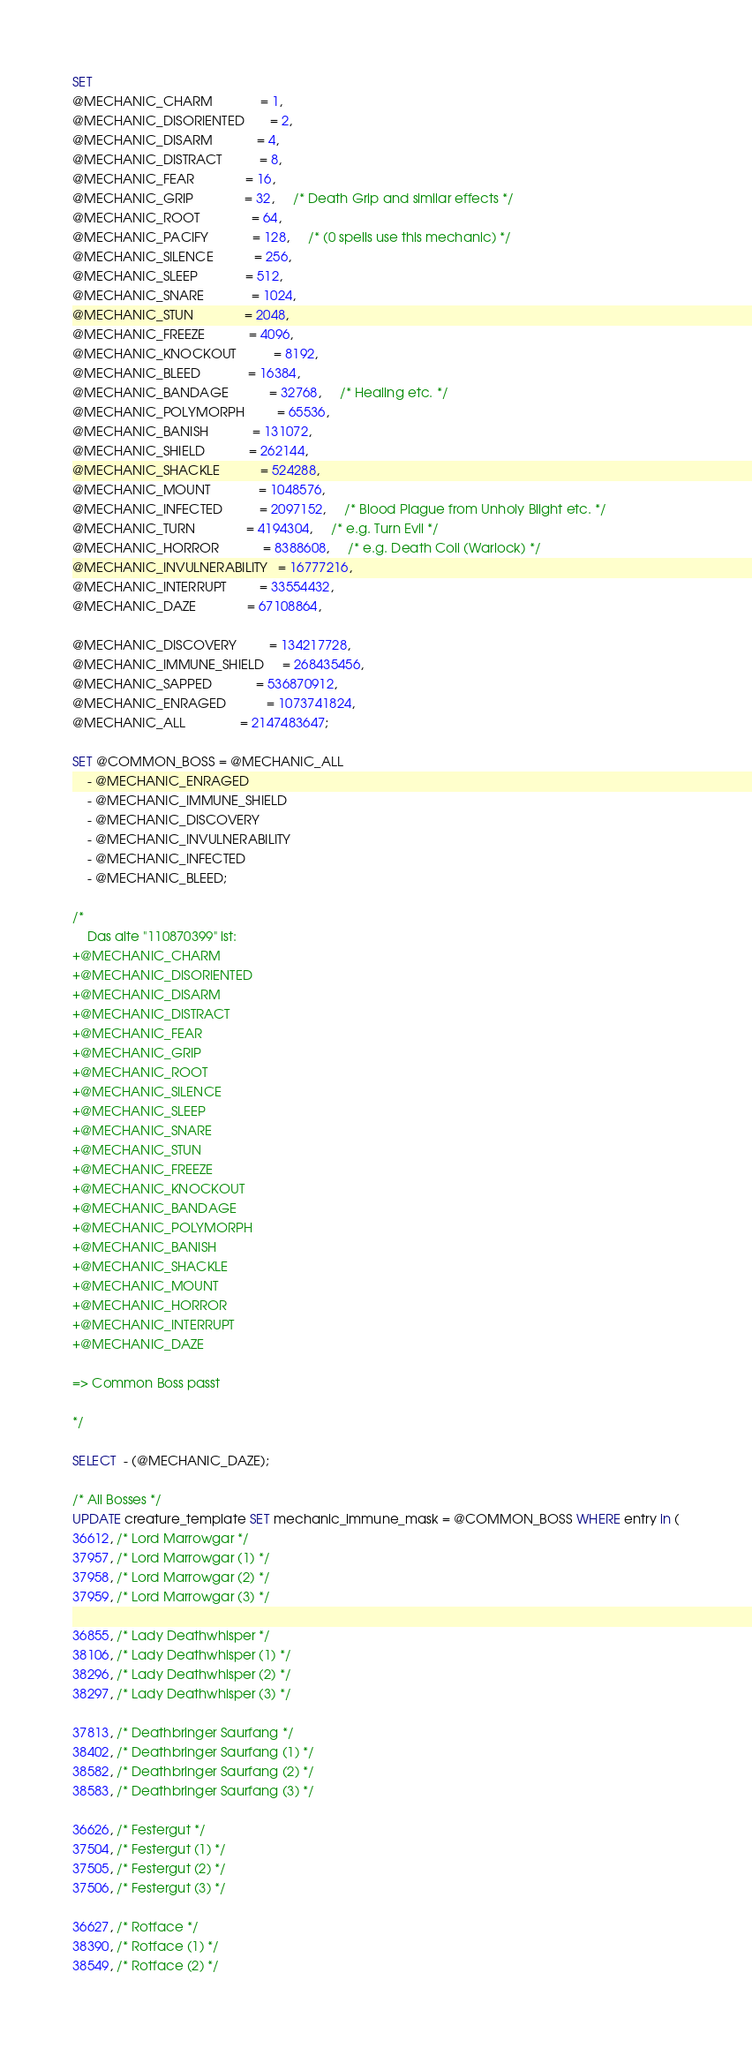Convert code to text. <code><loc_0><loc_0><loc_500><loc_500><_SQL_>SET 
@MECHANIC_CHARM             = 1,
@MECHANIC_DISORIENTED       = 2,     
@MECHANIC_DISARM            = 4,
@MECHANIC_DISTRACT          = 8,     
@MECHANIC_FEAR              = 16,     
@MECHANIC_GRIP              = 32,     /* Death Grip and similar effects */
@MECHANIC_ROOT              = 64,     
@MECHANIC_PACIFY            = 128,     /* (0 spells use this mechanic) */
@MECHANIC_SILENCE           = 256,     
@MECHANIC_SLEEP             = 512,     
@MECHANIC_SNARE             = 1024,     
@MECHANIC_STUN              = 2048,     
@MECHANIC_FREEZE            = 4096,     
@MECHANIC_KNOCKOUT          = 8192,     
@MECHANIC_BLEED             = 16384,     
@MECHANIC_BANDAGE           = 32768,     /* Healing etc. */
@MECHANIC_POLYMORPH         = 65536,     
@MECHANIC_BANISH            = 131072,     
@MECHANIC_SHIELD            = 262144,     
@MECHANIC_SHACKLE           = 524288,     
@MECHANIC_MOUNT             = 1048576,     
@MECHANIC_INFECTED          = 2097152,     /* Blood Plague from Unholy Blight etc. */
@MECHANIC_TURN              = 4194304,     /* e.g. Turn Evil */
@MECHANIC_HORROR            = 8388608,     /* e.g. Death Coil (Warlock) */
@MECHANIC_INVULNERABILITY   = 16777216,     
@MECHANIC_INTERRUPT         = 33554432,     
@MECHANIC_DAZE              = 67108864,
															
@MECHANIC_DISCOVERY         = 134217728,
@MECHANIC_IMMUNE_SHIELD     = 268435456,     
@MECHANIC_SAPPED            = 536870912,     
@MECHANIC_ENRAGED           = 1073741824,    
@MECHANIC_ALL               = 2147483647;

SET @COMMON_BOSS = @MECHANIC_ALL 
    - @MECHANIC_ENRAGED
    - @MECHANIC_IMMUNE_SHIELD
    - @MECHANIC_DISCOVERY
    - @MECHANIC_INVULNERABILITY
    - @MECHANIC_INFECTED
    - @MECHANIC_BLEED;
    
/*
	Das alte "110870399" ist:
+@MECHANIC_CHARM
+@MECHANIC_DISORIENTED
+@MECHANIC_DISARM
+@MECHANIC_DISTRACT
+@MECHANIC_FEAR
+@MECHANIC_GRIP
+@MECHANIC_ROOT
+@MECHANIC_SILENCE
+@MECHANIC_SLEEP
+@MECHANIC_SNARE
+@MECHANIC_STUN
+@MECHANIC_FREEZE
+@MECHANIC_KNOCKOUT
+@MECHANIC_BANDAGE
+@MECHANIC_POLYMORPH
+@MECHANIC_BANISH
+@MECHANIC_SHACKLE
+@MECHANIC_MOUNT
+@MECHANIC_HORROR
+@MECHANIC_INTERRUPT
+@MECHANIC_DAZE

=> Common Boss passt

*/    

SELECT  - (@MECHANIC_DAZE);

/* All Bosses */
UPDATE creature_template SET mechanic_immune_mask = @COMMON_BOSS WHERE entry in (
36612, /* Lord Marrowgar */
37957, /* Lord Marrowgar (1) */
37958, /* Lord Marrowgar (2) */
37959, /* Lord Marrowgar (3) */

36855, /* Lady Deathwhisper */
38106, /* Lady Deathwhisper (1) */
38296, /* Lady Deathwhisper (2) */
38297, /* Lady Deathwhisper (3) */

37813, /* Deathbringer Saurfang */
38402, /* Deathbringer Saurfang (1) */
38582, /* Deathbringer Saurfang (2) */
38583, /* Deathbringer Saurfang (3) */

36626, /* Festergut */
37504, /* Festergut (1) */
37505, /* Festergut (2) */
37506, /* Festergut (3) */

36627, /* Rotface */
38390, /* Rotface (1) */
38549, /* Rotface (2) */</code> 